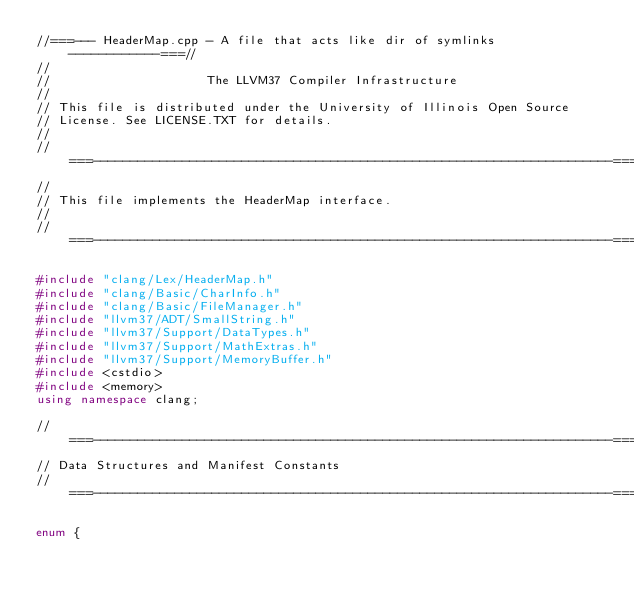Convert code to text. <code><loc_0><loc_0><loc_500><loc_500><_C++_>//===--- HeaderMap.cpp - A file that acts like dir of symlinks ------------===//
//
//                     The LLVM37 Compiler Infrastructure
//
// This file is distributed under the University of Illinois Open Source
// License. See LICENSE.TXT for details.
//
//===----------------------------------------------------------------------===//
//
// This file implements the HeaderMap interface.
//
//===----------------------------------------------------------------------===//

#include "clang/Lex/HeaderMap.h"
#include "clang/Basic/CharInfo.h"
#include "clang/Basic/FileManager.h"
#include "llvm37/ADT/SmallString.h"
#include "llvm37/Support/DataTypes.h"
#include "llvm37/Support/MathExtras.h"
#include "llvm37/Support/MemoryBuffer.h"
#include <cstdio>
#include <memory>
using namespace clang;

//===----------------------------------------------------------------------===//
// Data Structures and Manifest Constants
//===----------------------------------------------------------------------===//

enum {</code> 